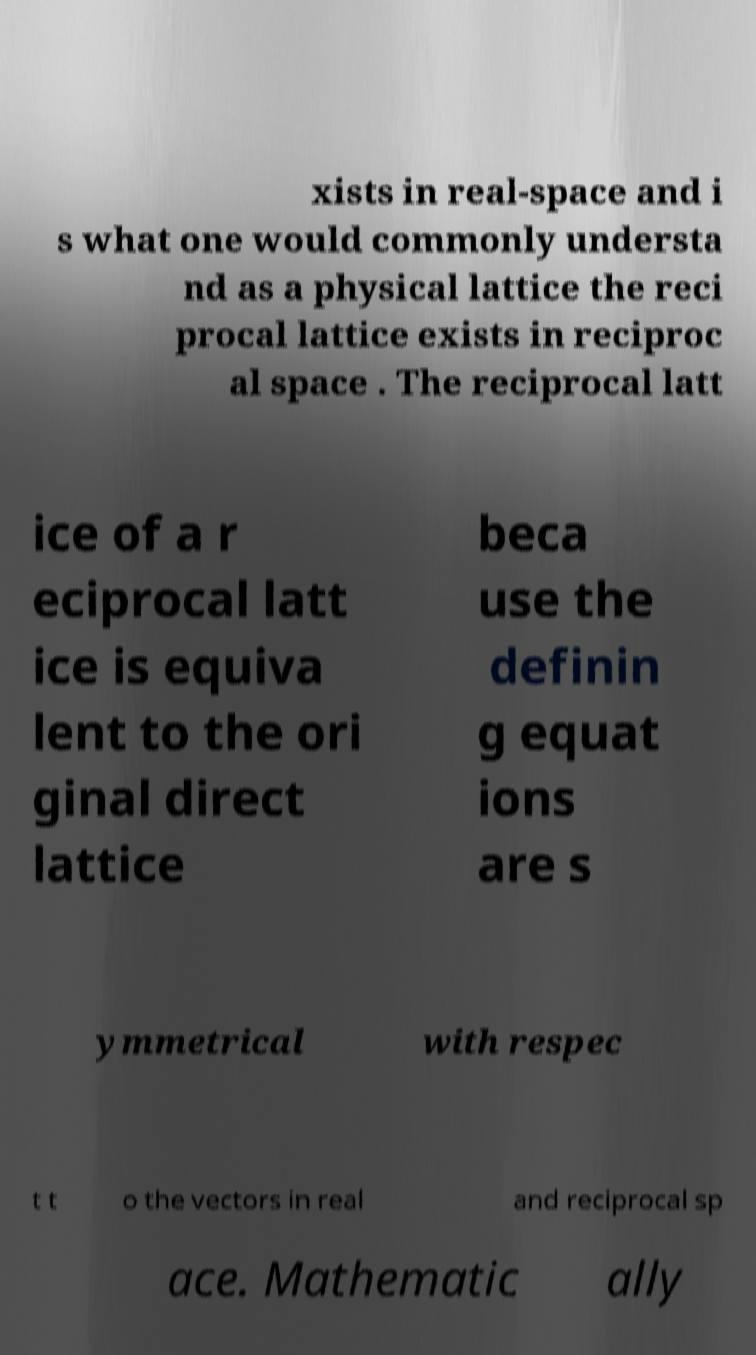What messages or text are displayed in this image? I need them in a readable, typed format. xists in real-space and i s what one would commonly understa nd as a physical lattice the reci procal lattice exists in reciproc al space . The reciprocal latt ice of a r eciprocal latt ice is equiva lent to the ori ginal direct lattice beca use the definin g equat ions are s ymmetrical with respec t t o the vectors in real and reciprocal sp ace. Mathematic ally 